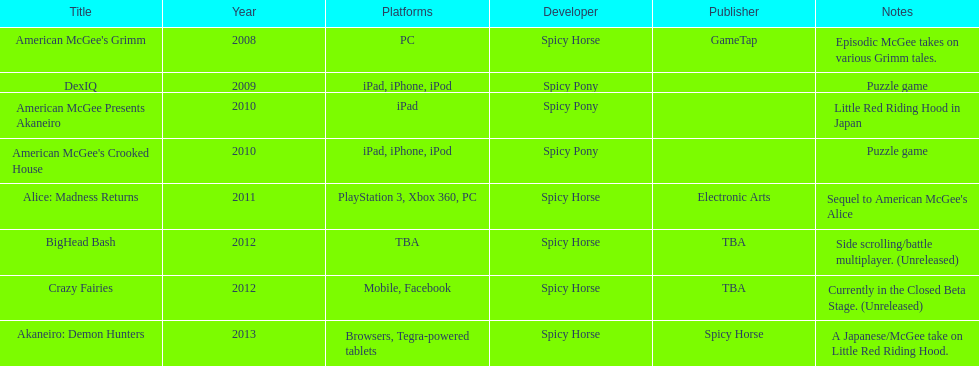How many platforms were compatible with american mcgee's grimm? 1. 